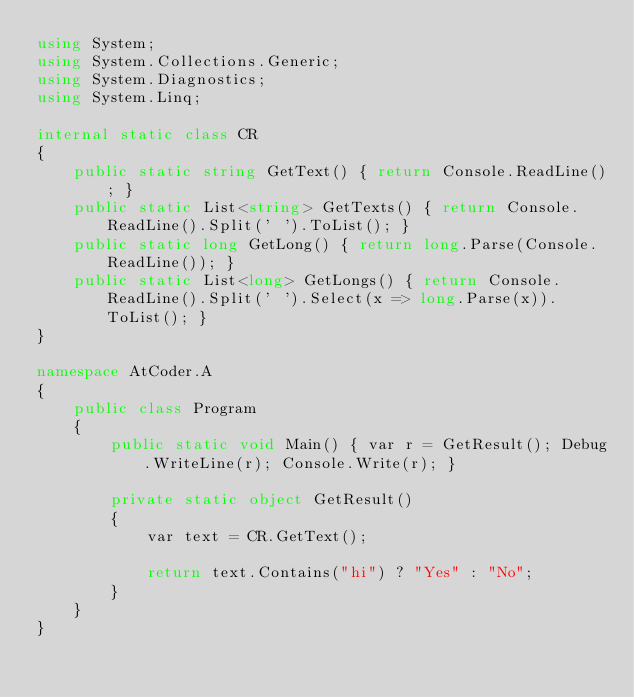Convert code to text. <code><loc_0><loc_0><loc_500><loc_500><_C#_>using System;
using System.Collections.Generic;
using System.Diagnostics;
using System.Linq;

internal static class CR
{
    public static string GetText() { return Console.ReadLine(); }
    public static List<string> GetTexts() { return Console.ReadLine().Split(' ').ToList(); }
    public static long GetLong() { return long.Parse(Console.ReadLine()); }
    public static List<long> GetLongs() { return Console.ReadLine().Split(' ').Select(x => long.Parse(x)).ToList(); }
}

namespace AtCoder.A
{
    public class Program
    {
        public static void Main() { var r = GetResult(); Debug.WriteLine(r); Console.Write(r); }

        private static object GetResult()
        {
            var text = CR.GetText();

            return text.Contains("hi") ? "Yes" : "No";
        }
    }
}
</code> 